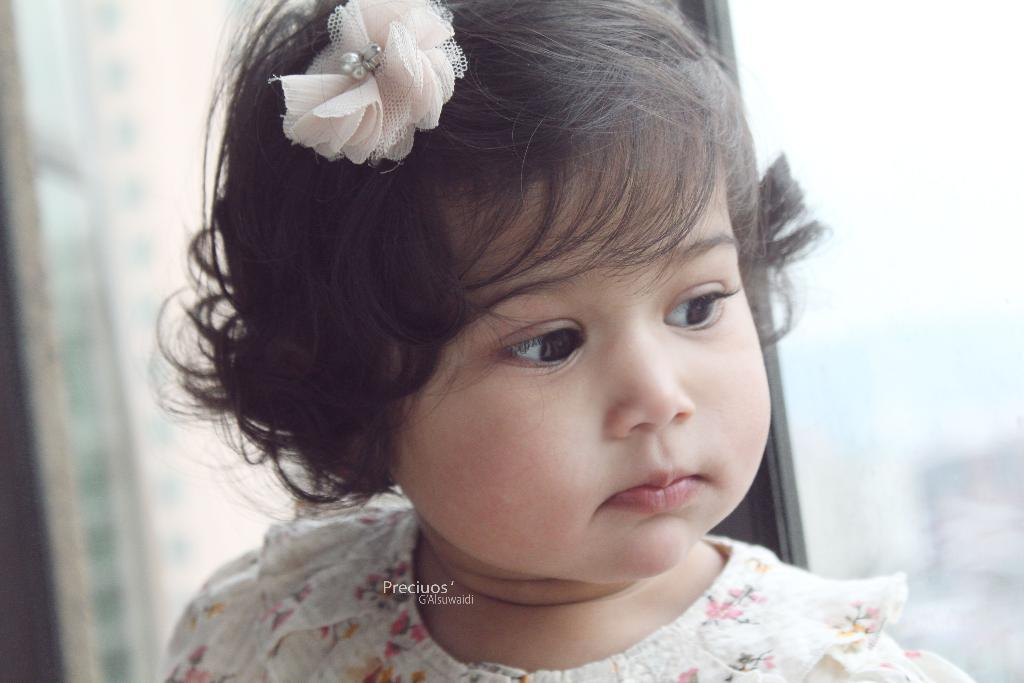What is the main subject in the foreground of the image? There is a kid in the foreground of the image. What can be seen in the background of the image? There is a window in the background of the image. Where is the image taken? The image is taken in a room. What type of feast is being prepared in the room in the image? There is no indication of a feast or any food preparation in the image; it primarily features a kid in the foreground and a window in the background. 